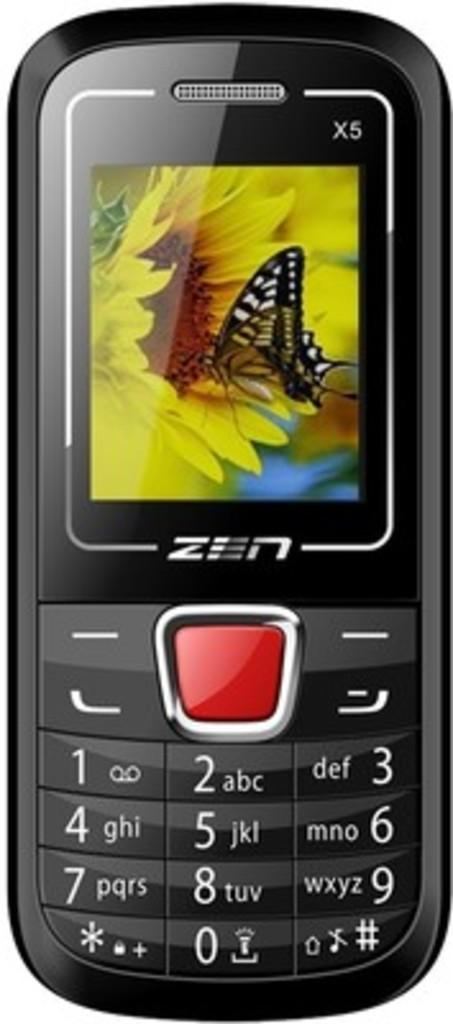<image>
Write a terse but informative summary of the picture. A ZEN branded cellphone with the background of a monarch butterfly on it. 